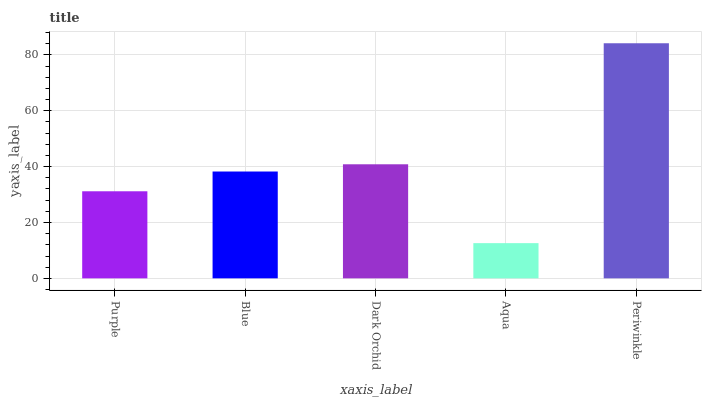Is Blue the minimum?
Answer yes or no. No. Is Blue the maximum?
Answer yes or no. No. Is Blue greater than Purple?
Answer yes or no. Yes. Is Purple less than Blue?
Answer yes or no. Yes. Is Purple greater than Blue?
Answer yes or no. No. Is Blue less than Purple?
Answer yes or no. No. Is Blue the high median?
Answer yes or no. Yes. Is Blue the low median?
Answer yes or no. Yes. Is Aqua the high median?
Answer yes or no. No. Is Purple the low median?
Answer yes or no. No. 